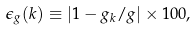Convert formula to latex. <formula><loc_0><loc_0><loc_500><loc_500>\epsilon _ { g } ( k ) \equiv | 1 - g _ { k } / g | \times 1 0 0 ,</formula> 